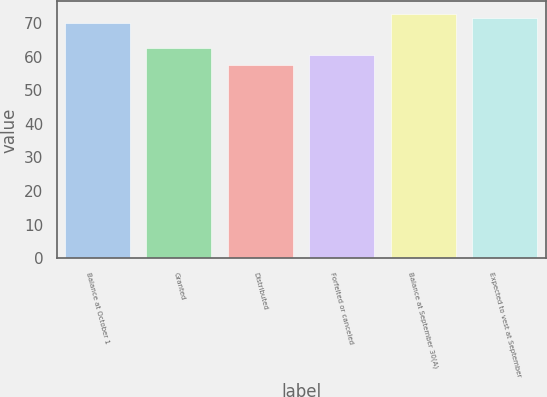<chart> <loc_0><loc_0><loc_500><loc_500><bar_chart><fcel>Balance at October 1<fcel>Granted<fcel>Distributed<fcel>Forfeited or canceled<fcel>Balance at September 30(A)<fcel>Expected to vest at September<nl><fcel>69.98<fcel>62.5<fcel>57.49<fcel>60.55<fcel>72.76<fcel>71.37<nl></chart> 